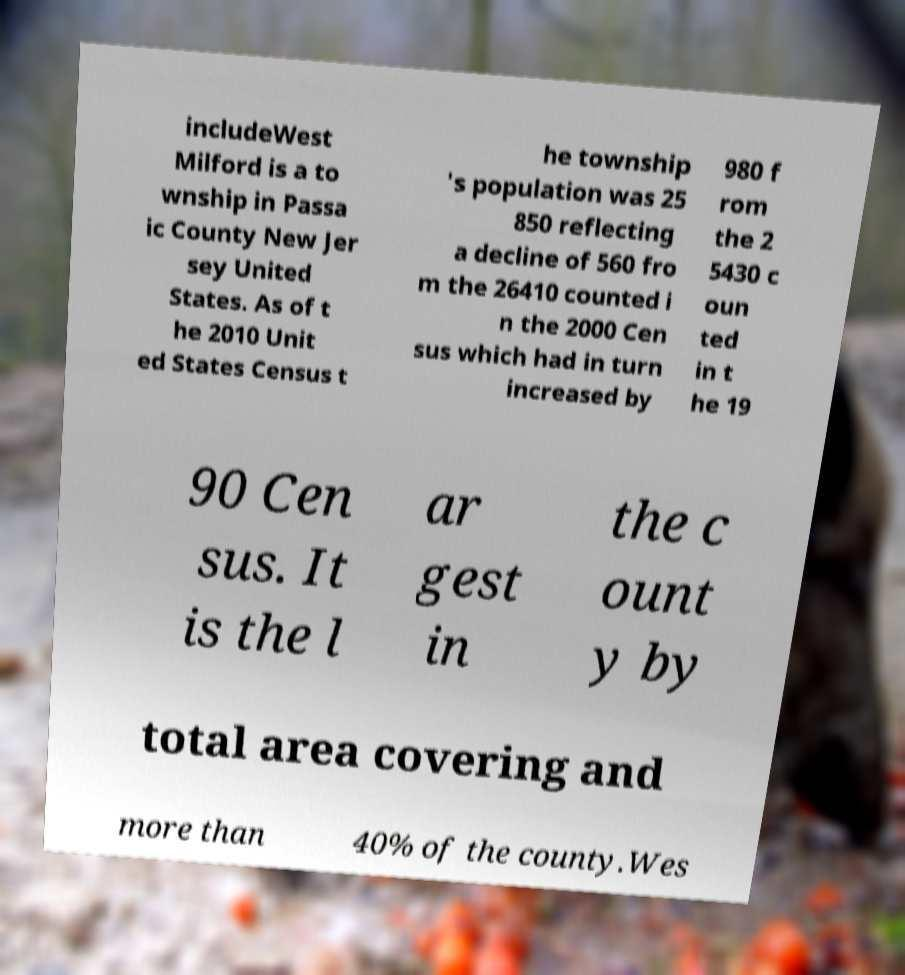Could you assist in decoding the text presented in this image and type it out clearly? includeWest Milford is a to wnship in Passa ic County New Jer sey United States. As of t he 2010 Unit ed States Census t he township 's population was 25 850 reflecting a decline of 560 fro m the 26410 counted i n the 2000 Cen sus which had in turn increased by 980 f rom the 2 5430 c oun ted in t he 19 90 Cen sus. It is the l ar gest in the c ount y by total area covering and more than 40% of the county.Wes 